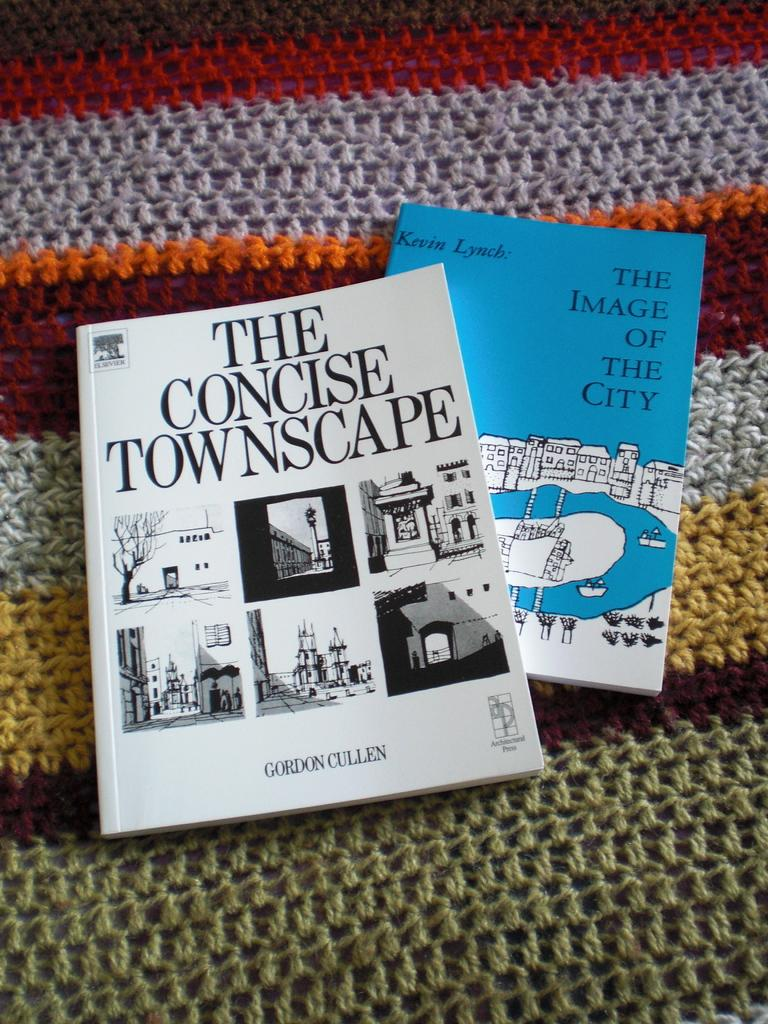<image>
Give a short and clear explanation of the subsequent image. Two different book, by different authors, placed on a fabric. 